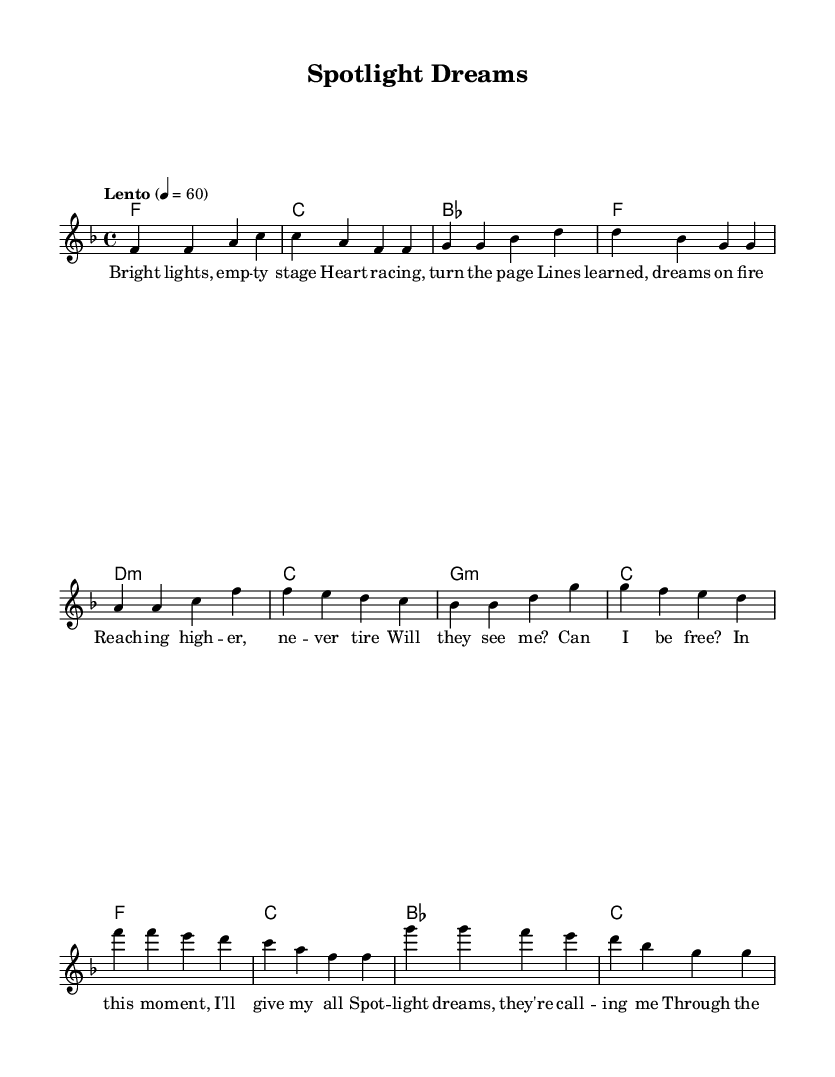What is the key signature of this music? The key signature indicates F major, which contains one flat (B flat). This can be identified by looking at the key signature at the beginning of the score.
Answer: F major What is the time signature of this music? The time signature is 4/4, which means there are four beats in each measure and the quarter note gets one beat. This is indicated at the beginning of the score.
Answer: 4/4 What is the tempo of the piece? The tempo marking states "Lento" with a metronome marking of 60, indicating a slow pace of 60 beats per minute. This can be found in the tempo indication at the start of the score.
Answer: 60 How many measures are present in the chorus section? The chorus consists of four measures, which can be counted by looking at the notation for that section in the music.
Answer: 4 What is the primary theme of the lyrics? The primary theme revolves around an actor's journey dealing with aspirations and struggles, emphasizing emotional expression in the face of challenges. This can be inferred from the content of the lyrics provided.
Answer: Acting journey What is the harmonic structure of the pre-chorus? The harmonic structure of the pre-chorus is built on the chords D minor, C major, G minor, and C major, as seen in the chord mode section corresponding to that part of the lyrics.
Answer: D minor, C major, G minor, C major What musical elements make this piece representative of K-Pop? The piece features emotional ballad lyrics, a catchy melody, and a structured format (verse, pre-chorus, chorus), which are characteristic elements of K-Pop. This can be deduced by considering the typical style and themes in K-Pop music.
Answer: Emotional ballad 